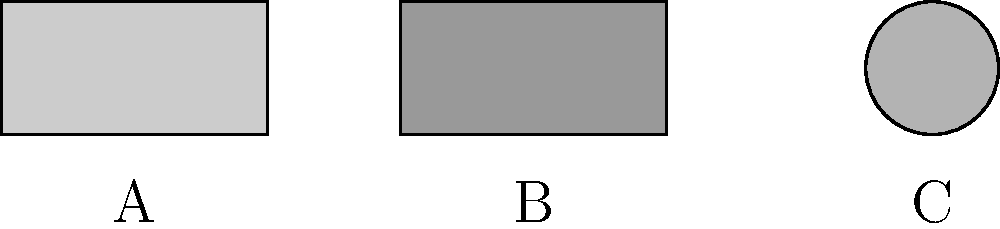As a new dad, you're learning about different types of diaper fasteners. Based on the simple diagrams above, which fastener type is most likely to be adjustable for a growing baby? Let's analyze each fastener type shown in the diagram:

1. Fastener A: This appears to be an adhesive tape fastener. It's a strip with a uniform shape, typically found on disposable diapers. While it can be adjusted to some extent, it's not ideal for significant size changes.

2. Fastener B: This resembles a Velcro or hook-and-loop fastener. It has a rectangular shape with a textured appearance. Velcro fasteners are known for their adjustability, as they can be attached at various points along the diaper's surface.

3. Fastener C: This circular shape likely represents a snap or button fastener. While snaps can offer multiple attachment points, they are usually limited to a few fixed positions.

Among these options, Fastener B (Velcro) provides the most flexibility for adjusting to a growing baby's size. It allows for minute adjustments and can accommodate a wide range of sizes as the baby grows.
Answer: B (Velcro fastener) 